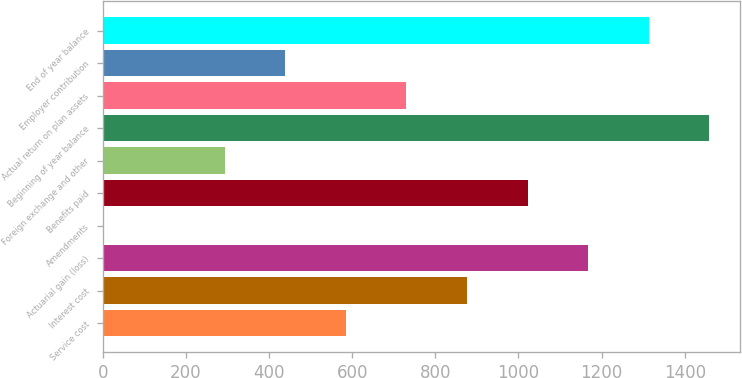Convert chart. <chart><loc_0><loc_0><loc_500><loc_500><bar_chart><fcel>Service cost<fcel>Interest cost<fcel>Actuarial gain (loss)<fcel>Amendments<fcel>Benefits paid<fcel>Foreign exchange and other<fcel>Beginning of year balance<fcel>Actual return on plan assets<fcel>Employer contribution<fcel>End of year balance<nl><fcel>584.8<fcel>876.2<fcel>1167.6<fcel>2<fcel>1021.9<fcel>293.4<fcel>1459<fcel>730.5<fcel>439.1<fcel>1313.3<nl></chart> 